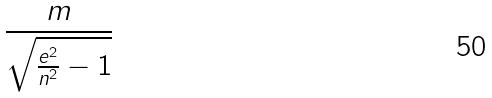Convert formula to latex. <formula><loc_0><loc_0><loc_500><loc_500>\frac { m } { \sqrt { \frac { e ^ { 2 } } { n ^ { 2 } } - 1 } }</formula> 